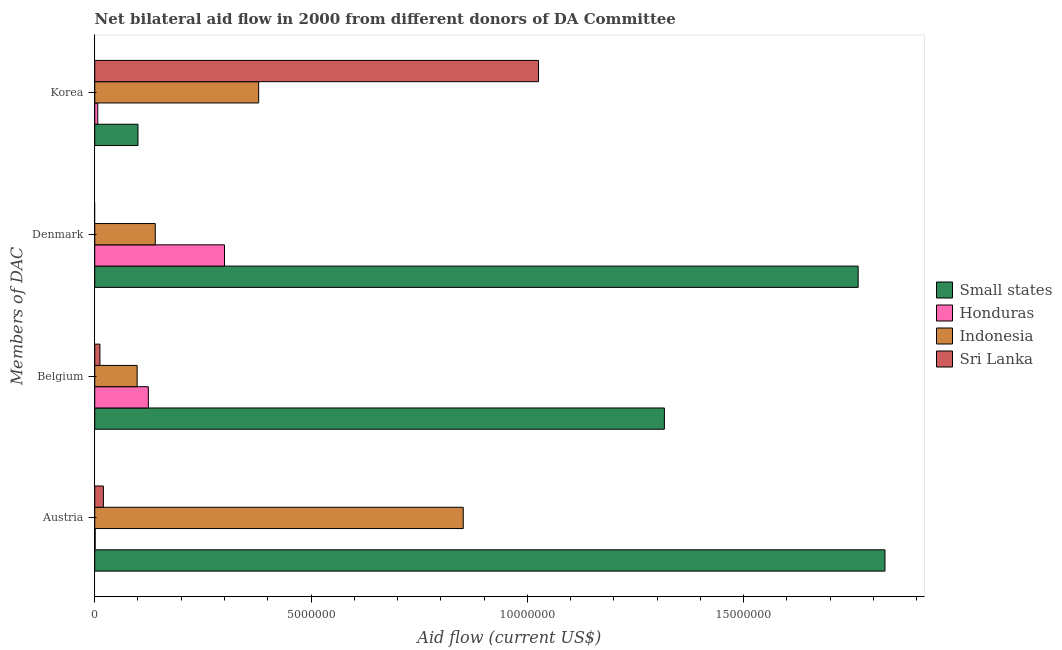How many different coloured bars are there?
Keep it short and to the point. 4. How many groups of bars are there?
Your answer should be very brief. 4. How many bars are there on the 3rd tick from the top?
Provide a short and direct response. 4. How many bars are there on the 3rd tick from the bottom?
Provide a succinct answer. 3. What is the amount of aid given by korea in Sri Lanka?
Provide a succinct answer. 1.03e+07. Across all countries, what is the maximum amount of aid given by korea?
Offer a very short reply. 1.03e+07. In which country was the amount of aid given by korea maximum?
Ensure brevity in your answer.  Sri Lanka. What is the total amount of aid given by austria in the graph?
Provide a succinct answer. 2.70e+07. What is the difference between the amount of aid given by austria in Honduras and that in Indonesia?
Offer a terse response. -8.51e+06. What is the difference between the amount of aid given by austria in Indonesia and the amount of aid given by denmark in Honduras?
Offer a very short reply. 5.52e+06. What is the average amount of aid given by korea per country?
Make the answer very short. 3.78e+06. What is the difference between the amount of aid given by korea and amount of aid given by austria in Small states?
Give a very brief answer. -1.73e+07. In how many countries, is the amount of aid given by belgium greater than 11000000 US$?
Make the answer very short. 1. What is the ratio of the amount of aid given by austria in Small states to that in Indonesia?
Keep it short and to the point. 2.14. What is the difference between the highest and the second highest amount of aid given by belgium?
Provide a short and direct response. 1.19e+07. What is the difference between the highest and the lowest amount of aid given by belgium?
Your answer should be compact. 1.30e+07. How many bars are there?
Your answer should be compact. 15. Are the values on the major ticks of X-axis written in scientific E-notation?
Your response must be concise. No. Does the graph contain grids?
Your response must be concise. No. What is the title of the graph?
Provide a short and direct response. Net bilateral aid flow in 2000 from different donors of DA Committee. What is the label or title of the X-axis?
Make the answer very short. Aid flow (current US$). What is the label or title of the Y-axis?
Your response must be concise. Members of DAC. What is the Aid flow (current US$) in Small states in Austria?
Provide a short and direct response. 1.83e+07. What is the Aid flow (current US$) of Honduras in Austria?
Offer a very short reply. 10000. What is the Aid flow (current US$) in Indonesia in Austria?
Keep it short and to the point. 8.52e+06. What is the Aid flow (current US$) of Sri Lanka in Austria?
Keep it short and to the point. 2.00e+05. What is the Aid flow (current US$) in Small states in Belgium?
Your answer should be compact. 1.32e+07. What is the Aid flow (current US$) of Honduras in Belgium?
Provide a short and direct response. 1.24e+06. What is the Aid flow (current US$) of Indonesia in Belgium?
Give a very brief answer. 9.80e+05. What is the Aid flow (current US$) of Sri Lanka in Belgium?
Your response must be concise. 1.20e+05. What is the Aid flow (current US$) of Small states in Denmark?
Your answer should be very brief. 1.76e+07. What is the Aid flow (current US$) of Indonesia in Denmark?
Your answer should be compact. 1.40e+06. What is the Aid flow (current US$) of Small states in Korea?
Make the answer very short. 1.00e+06. What is the Aid flow (current US$) in Indonesia in Korea?
Offer a very short reply. 3.79e+06. What is the Aid flow (current US$) in Sri Lanka in Korea?
Give a very brief answer. 1.03e+07. Across all Members of DAC, what is the maximum Aid flow (current US$) in Small states?
Give a very brief answer. 1.83e+07. Across all Members of DAC, what is the maximum Aid flow (current US$) in Honduras?
Offer a very short reply. 3.00e+06. Across all Members of DAC, what is the maximum Aid flow (current US$) in Indonesia?
Make the answer very short. 8.52e+06. Across all Members of DAC, what is the maximum Aid flow (current US$) in Sri Lanka?
Give a very brief answer. 1.03e+07. Across all Members of DAC, what is the minimum Aid flow (current US$) of Indonesia?
Ensure brevity in your answer.  9.80e+05. What is the total Aid flow (current US$) in Small states in the graph?
Make the answer very short. 5.01e+07. What is the total Aid flow (current US$) of Honduras in the graph?
Provide a short and direct response. 4.32e+06. What is the total Aid flow (current US$) of Indonesia in the graph?
Offer a terse response. 1.47e+07. What is the total Aid flow (current US$) in Sri Lanka in the graph?
Your answer should be compact. 1.06e+07. What is the difference between the Aid flow (current US$) in Small states in Austria and that in Belgium?
Give a very brief answer. 5.10e+06. What is the difference between the Aid flow (current US$) of Honduras in Austria and that in Belgium?
Provide a short and direct response. -1.23e+06. What is the difference between the Aid flow (current US$) in Indonesia in Austria and that in Belgium?
Offer a terse response. 7.54e+06. What is the difference between the Aid flow (current US$) of Sri Lanka in Austria and that in Belgium?
Provide a short and direct response. 8.00e+04. What is the difference between the Aid flow (current US$) in Small states in Austria and that in Denmark?
Your answer should be compact. 6.20e+05. What is the difference between the Aid flow (current US$) in Honduras in Austria and that in Denmark?
Make the answer very short. -2.99e+06. What is the difference between the Aid flow (current US$) in Indonesia in Austria and that in Denmark?
Your response must be concise. 7.12e+06. What is the difference between the Aid flow (current US$) in Small states in Austria and that in Korea?
Provide a short and direct response. 1.73e+07. What is the difference between the Aid flow (current US$) of Indonesia in Austria and that in Korea?
Provide a short and direct response. 4.73e+06. What is the difference between the Aid flow (current US$) in Sri Lanka in Austria and that in Korea?
Offer a very short reply. -1.01e+07. What is the difference between the Aid flow (current US$) of Small states in Belgium and that in Denmark?
Give a very brief answer. -4.48e+06. What is the difference between the Aid flow (current US$) of Honduras in Belgium and that in Denmark?
Offer a terse response. -1.76e+06. What is the difference between the Aid flow (current US$) of Indonesia in Belgium and that in Denmark?
Offer a terse response. -4.20e+05. What is the difference between the Aid flow (current US$) in Small states in Belgium and that in Korea?
Your answer should be compact. 1.22e+07. What is the difference between the Aid flow (current US$) in Honduras in Belgium and that in Korea?
Provide a short and direct response. 1.17e+06. What is the difference between the Aid flow (current US$) in Indonesia in Belgium and that in Korea?
Provide a succinct answer. -2.81e+06. What is the difference between the Aid flow (current US$) of Sri Lanka in Belgium and that in Korea?
Your response must be concise. -1.01e+07. What is the difference between the Aid flow (current US$) in Small states in Denmark and that in Korea?
Give a very brief answer. 1.66e+07. What is the difference between the Aid flow (current US$) in Honduras in Denmark and that in Korea?
Your answer should be very brief. 2.93e+06. What is the difference between the Aid flow (current US$) in Indonesia in Denmark and that in Korea?
Offer a terse response. -2.39e+06. What is the difference between the Aid flow (current US$) of Small states in Austria and the Aid flow (current US$) of Honduras in Belgium?
Your answer should be very brief. 1.70e+07. What is the difference between the Aid flow (current US$) of Small states in Austria and the Aid flow (current US$) of Indonesia in Belgium?
Provide a succinct answer. 1.73e+07. What is the difference between the Aid flow (current US$) of Small states in Austria and the Aid flow (current US$) of Sri Lanka in Belgium?
Keep it short and to the point. 1.82e+07. What is the difference between the Aid flow (current US$) of Honduras in Austria and the Aid flow (current US$) of Indonesia in Belgium?
Give a very brief answer. -9.70e+05. What is the difference between the Aid flow (current US$) in Honduras in Austria and the Aid flow (current US$) in Sri Lanka in Belgium?
Provide a short and direct response. -1.10e+05. What is the difference between the Aid flow (current US$) in Indonesia in Austria and the Aid flow (current US$) in Sri Lanka in Belgium?
Keep it short and to the point. 8.40e+06. What is the difference between the Aid flow (current US$) of Small states in Austria and the Aid flow (current US$) of Honduras in Denmark?
Your answer should be very brief. 1.53e+07. What is the difference between the Aid flow (current US$) of Small states in Austria and the Aid flow (current US$) of Indonesia in Denmark?
Make the answer very short. 1.69e+07. What is the difference between the Aid flow (current US$) in Honduras in Austria and the Aid flow (current US$) in Indonesia in Denmark?
Your response must be concise. -1.39e+06. What is the difference between the Aid flow (current US$) of Small states in Austria and the Aid flow (current US$) of Honduras in Korea?
Provide a short and direct response. 1.82e+07. What is the difference between the Aid flow (current US$) of Small states in Austria and the Aid flow (current US$) of Indonesia in Korea?
Offer a very short reply. 1.45e+07. What is the difference between the Aid flow (current US$) of Small states in Austria and the Aid flow (current US$) of Sri Lanka in Korea?
Your answer should be compact. 8.01e+06. What is the difference between the Aid flow (current US$) of Honduras in Austria and the Aid flow (current US$) of Indonesia in Korea?
Make the answer very short. -3.78e+06. What is the difference between the Aid flow (current US$) of Honduras in Austria and the Aid flow (current US$) of Sri Lanka in Korea?
Your answer should be compact. -1.02e+07. What is the difference between the Aid flow (current US$) in Indonesia in Austria and the Aid flow (current US$) in Sri Lanka in Korea?
Your answer should be compact. -1.74e+06. What is the difference between the Aid flow (current US$) in Small states in Belgium and the Aid flow (current US$) in Honduras in Denmark?
Offer a very short reply. 1.02e+07. What is the difference between the Aid flow (current US$) of Small states in Belgium and the Aid flow (current US$) of Indonesia in Denmark?
Keep it short and to the point. 1.18e+07. What is the difference between the Aid flow (current US$) of Honduras in Belgium and the Aid flow (current US$) of Indonesia in Denmark?
Your answer should be compact. -1.60e+05. What is the difference between the Aid flow (current US$) in Small states in Belgium and the Aid flow (current US$) in Honduras in Korea?
Ensure brevity in your answer.  1.31e+07. What is the difference between the Aid flow (current US$) in Small states in Belgium and the Aid flow (current US$) in Indonesia in Korea?
Your answer should be compact. 9.38e+06. What is the difference between the Aid flow (current US$) of Small states in Belgium and the Aid flow (current US$) of Sri Lanka in Korea?
Offer a terse response. 2.91e+06. What is the difference between the Aid flow (current US$) in Honduras in Belgium and the Aid flow (current US$) in Indonesia in Korea?
Your answer should be very brief. -2.55e+06. What is the difference between the Aid flow (current US$) of Honduras in Belgium and the Aid flow (current US$) of Sri Lanka in Korea?
Give a very brief answer. -9.02e+06. What is the difference between the Aid flow (current US$) of Indonesia in Belgium and the Aid flow (current US$) of Sri Lanka in Korea?
Your answer should be very brief. -9.28e+06. What is the difference between the Aid flow (current US$) of Small states in Denmark and the Aid flow (current US$) of Honduras in Korea?
Your answer should be very brief. 1.76e+07. What is the difference between the Aid flow (current US$) in Small states in Denmark and the Aid flow (current US$) in Indonesia in Korea?
Provide a succinct answer. 1.39e+07. What is the difference between the Aid flow (current US$) in Small states in Denmark and the Aid flow (current US$) in Sri Lanka in Korea?
Your answer should be compact. 7.39e+06. What is the difference between the Aid flow (current US$) in Honduras in Denmark and the Aid flow (current US$) in Indonesia in Korea?
Ensure brevity in your answer.  -7.90e+05. What is the difference between the Aid flow (current US$) of Honduras in Denmark and the Aid flow (current US$) of Sri Lanka in Korea?
Your answer should be compact. -7.26e+06. What is the difference between the Aid flow (current US$) of Indonesia in Denmark and the Aid flow (current US$) of Sri Lanka in Korea?
Your answer should be very brief. -8.86e+06. What is the average Aid flow (current US$) of Small states per Members of DAC?
Your response must be concise. 1.25e+07. What is the average Aid flow (current US$) of Honduras per Members of DAC?
Your response must be concise. 1.08e+06. What is the average Aid flow (current US$) in Indonesia per Members of DAC?
Provide a short and direct response. 3.67e+06. What is the average Aid flow (current US$) in Sri Lanka per Members of DAC?
Make the answer very short. 2.64e+06. What is the difference between the Aid flow (current US$) in Small states and Aid flow (current US$) in Honduras in Austria?
Provide a short and direct response. 1.83e+07. What is the difference between the Aid flow (current US$) of Small states and Aid flow (current US$) of Indonesia in Austria?
Your response must be concise. 9.75e+06. What is the difference between the Aid flow (current US$) in Small states and Aid flow (current US$) in Sri Lanka in Austria?
Make the answer very short. 1.81e+07. What is the difference between the Aid flow (current US$) of Honduras and Aid flow (current US$) of Indonesia in Austria?
Give a very brief answer. -8.51e+06. What is the difference between the Aid flow (current US$) of Indonesia and Aid flow (current US$) of Sri Lanka in Austria?
Offer a very short reply. 8.32e+06. What is the difference between the Aid flow (current US$) in Small states and Aid flow (current US$) in Honduras in Belgium?
Your response must be concise. 1.19e+07. What is the difference between the Aid flow (current US$) of Small states and Aid flow (current US$) of Indonesia in Belgium?
Ensure brevity in your answer.  1.22e+07. What is the difference between the Aid flow (current US$) in Small states and Aid flow (current US$) in Sri Lanka in Belgium?
Your answer should be compact. 1.30e+07. What is the difference between the Aid flow (current US$) of Honduras and Aid flow (current US$) of Sri Lanka in Belgium?
Your answer should be compact. 1.12e+06. What is the difference between the Aid flow (current US$) of Indonesia and Aid flow (current US$) of Sri Lanka in Belgium?
Offer a terse response. 8.60e+05. What is the difference between the Aid flow (current US$) of Small states and Aid flow (current US$) of Honduras in Denmark?
Your answer should be compact. 1.46e+07. What is the difference between the Aid flow (current US$) in Small states and Aid flow (current US$) in Indonesia in Denmark?
Offer a very short reply. 1.62e+07. What is the difference between the Aid flow (current US$) of Honduras and Aid flow (current US$) of Indonesia in Denmark?
Offer a very short reply. 1.60e+06. What is the difference between the Aid flow (current US$) in Small states and Aid flow (current US$) in Honduras in Korea?
Your answer should be very brief. 9.30e+05. What is the difference between the Aid flow (current US$) in Small states and Aid flow (current US$) in Indonesia in Korea?
Provide a succinct answer. -2.79e+06. What is the difference between the Aid flow (current US$) in Small states and Aid flow (current US$) in Sri Lanka in Korea?
Keep it short and to the point. -9.26e+06. What is the difference between the Aid flow (current US$) in Honduras and Aid flow (current US$) in Indonesia in Korea?
Provide a succinct answer. -3.72e+06. What is the difference between the Aid flow (current US$) of Honduras and Aid flow (current US$) of Sri Lanka in Korea?
Keep it short and to the point. -1.02e+07. What is the difference between the Aid flow (current US$) of Indonesia and Aid flow (current US$) of Sri Lanka in Korea?
Give a very brief answer. -6.47e+06. What is the ratio of the Aid flow (current US$) in Small states in Austria to that in Belgium?
Your response must be concise. 1.39. What is the ratio of the Aid flow (current US$) in Honduras in Austria to that in Belgium?
Your answer should be compact. 0.01. What is the ratio of the Aid flow (current US$) of Indonesia in Austria to that in Belgium?
Your response must be concise. 8.69. What is the ratio of the Aid flow (current US$) in Small states in Austria to that in Denmark?
Give a very brief answer. 1.04. What is the ratio of the Aid flow (current US$) of Honduras in Austria to that in Denmark?
Offer a terse response. 0. What is the ratio of the Aid flow (current US$) of Indonesia in Austria to that in Denmark?
Make the answer very short. 6.09. What is the ratio of the Aid flow (current US$) of Small states in Austria to that in Korea?
Ensure brevity in your answer.  18.27. What is the ratio of the Aid flow (current US$) in Honduras in Austria to that in Korea?
Your answer should be very brief. 0.14. What is the ratio of the Aid flow (current US$) in Indonesia in Austria to that in Korea?
Provide a succinct answer. 2.25. What is the ratio of the Aid flow (current US$) in Sri Lanka in Austria to that in Korea?
Provide a succinct answer. 0.02. What is the ratio of the Aid flow (current US$) of Small states in Belgium to that in Denmark?
Make the answer very short. 0.75. What is the ratio of the Aid flow (current US$) in Honduras in Belgium to that in Denmark?
Make the answer very short. 0.41. What is the ratio of the Aid flow (current US$) of Indonesia in Belgium to that in Denmark?
Offer a terse response. 0.7. What is the ratio of the Aid flow (current US$) in Small states in Belgium to that in Korea?
Give a very brief answer. 13.17. What is the ratio of the Aid flow (current US$) in Honduras in Belgium to that in Korea?
Provide a succinct answer. 17.71. What is the ratio of the Aid flow (current US$) in Indonesia in Belgium to that in Korea?
Provide a succinct answer. 0.26. What is the ratio of the Aid flow (current US$) in Sri Lanka in Belgium to that in Korea?
Your answer should be compact. 0.01. What is the ratio of the Aid flow (current US$) of Small states in Denmark to that in Korea?
Offer a very short reply. 17.65. What is the ratio of the Aid flow (current US$) of Honduras in Denmark to that in Korea?
Ensure brevity in your answer.  42.86. What is the ratio of the Aid flow (current US$) of Indonesia in Denmark to that in Korea?
Make the answer very short. 0.37. What is the difference between the highest and the second highest Aid flow (current US$) in Small states?
Your response must be concise. 6.20e+05. What is the difference between the highest and the second highest Aid flow (current US$) of Honduras?
Provide a short and direct response. 1.76e+06. What is the difference between the highest and the second highest Aid flow (current US$) of Indonesia?
Your answer should be very brief. 4.73e+06. What is the difference between the highest and the second highest Aid flow (current US$) in Sri Lanka?
Make the answer very short. 1.01e+07. What is the difference between the highest and the lowest Aid flow (current US$) of Small states?
Your answer should be compact. 1.73e+07. What is the difference between the highest and the lowest Aid flow (current US$) of Honduras?
Provide a short and direct response. 2.99e+06. What is the difference between the highest and the lowest Aid flow (current US$) in Indonesia?
Provide a succinct answer. 7.54e+06. What is the difference between the highest and the lowest Aid flow (current US$) in Sri Lanka?
Your answer should be compact. 1.03e+07. 